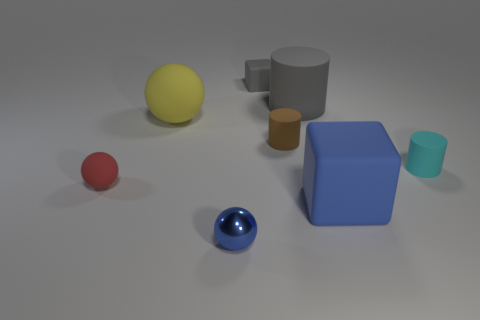Add 1 big brown shiny balls. How many objects exist? 9 Subtract all cylinders. How many objects are left? 5 Add 5 cubes. How many cubes exist? 7 Subtract 1 blue spheres. How many objects are left? 7 Subtract all red shiny spheres. Subtract all tiny blue objects. How many objects are left? 7 Add 3 small matte things. How many small matte things are left? 7 